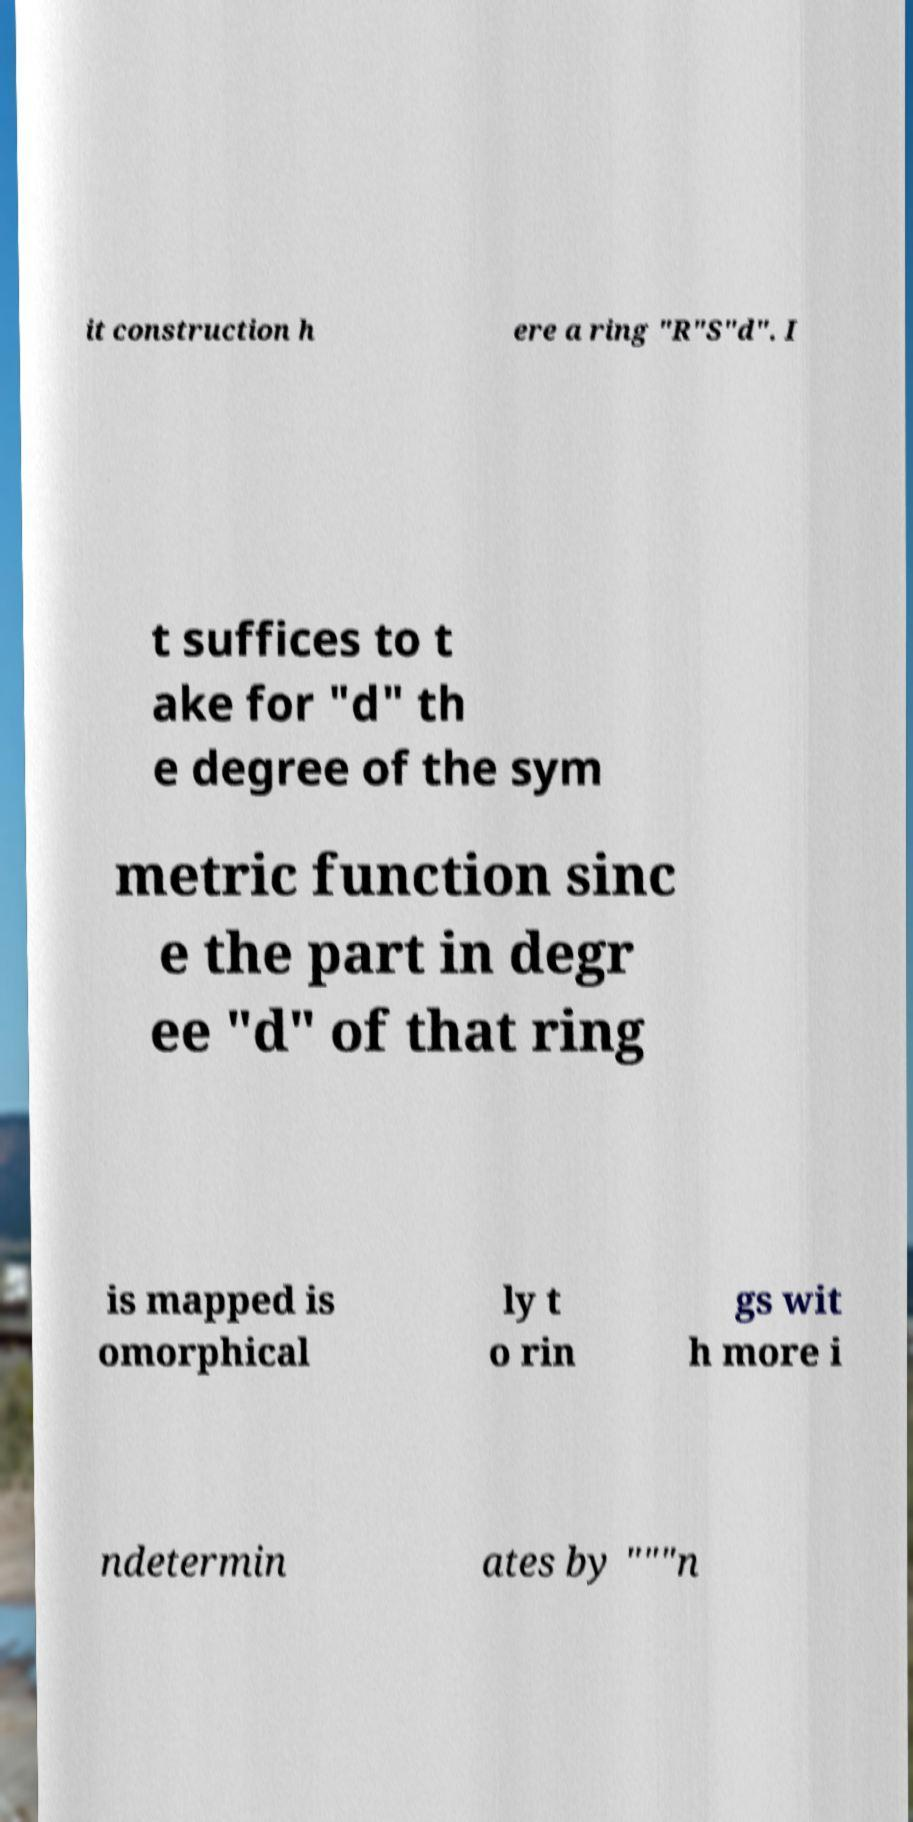There's text embedded in this image that I need extracted. Can you transcribe it verbatim? it construction h ere a ring "R"S"d". I t suffices to t ake for "d" th e degree of the sym metric function sinc e the part in degr ee "d" of that ring is mapped is omorphical ly t o rin gs wit h more i ndetermin ates by """n 